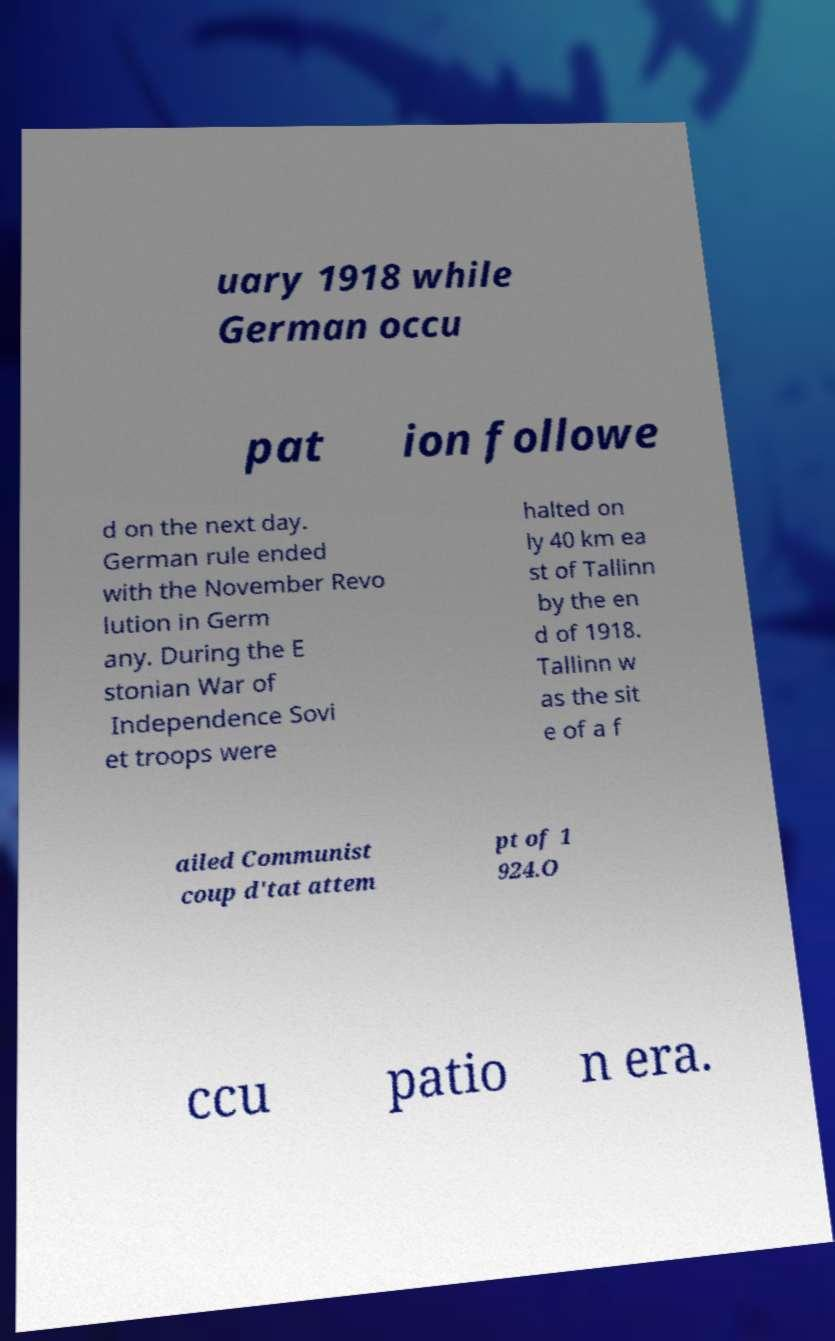There's text embedded in this image that I need extracted. Can you transcribe it verbatim? uary 1918 while German occu pat ion followe d on the next day. German rule ended with the November Revo lution in Germ any. During the E stonian War of Independence Sovi et troops were halted on ly 40 km ea st of Tallinn by the en d of 1918. Tallinn w as the sit e of a f ailed Communist coup d'tat attem pt of 1 924.O ccu patio n era. 